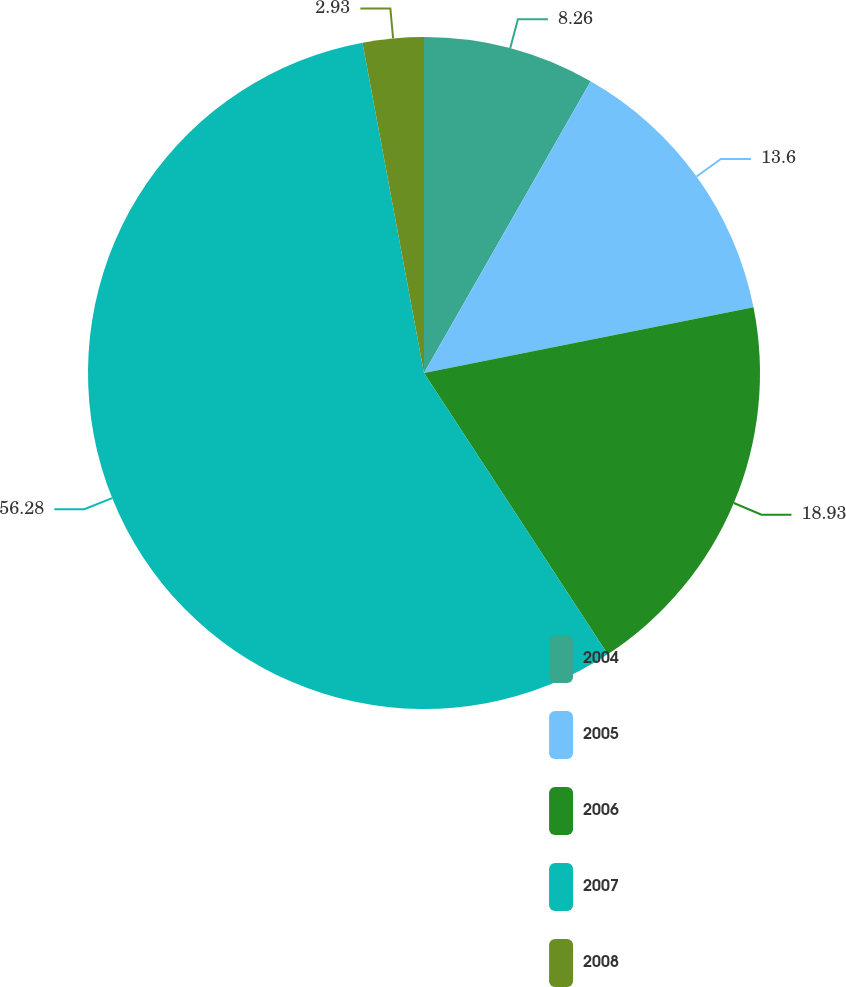Convert chart. <chart><loc_0><loc_0><loc_500><loc_500><pie_chart><fcel>2004<fcel>2005<fcel>2006<fcel>2007<fcel>2008<nl><fcel>8.26%<fcel>13.6%<fcel>18.93%<fcel>56.28%<fcel>2.93%<nl></chart> 